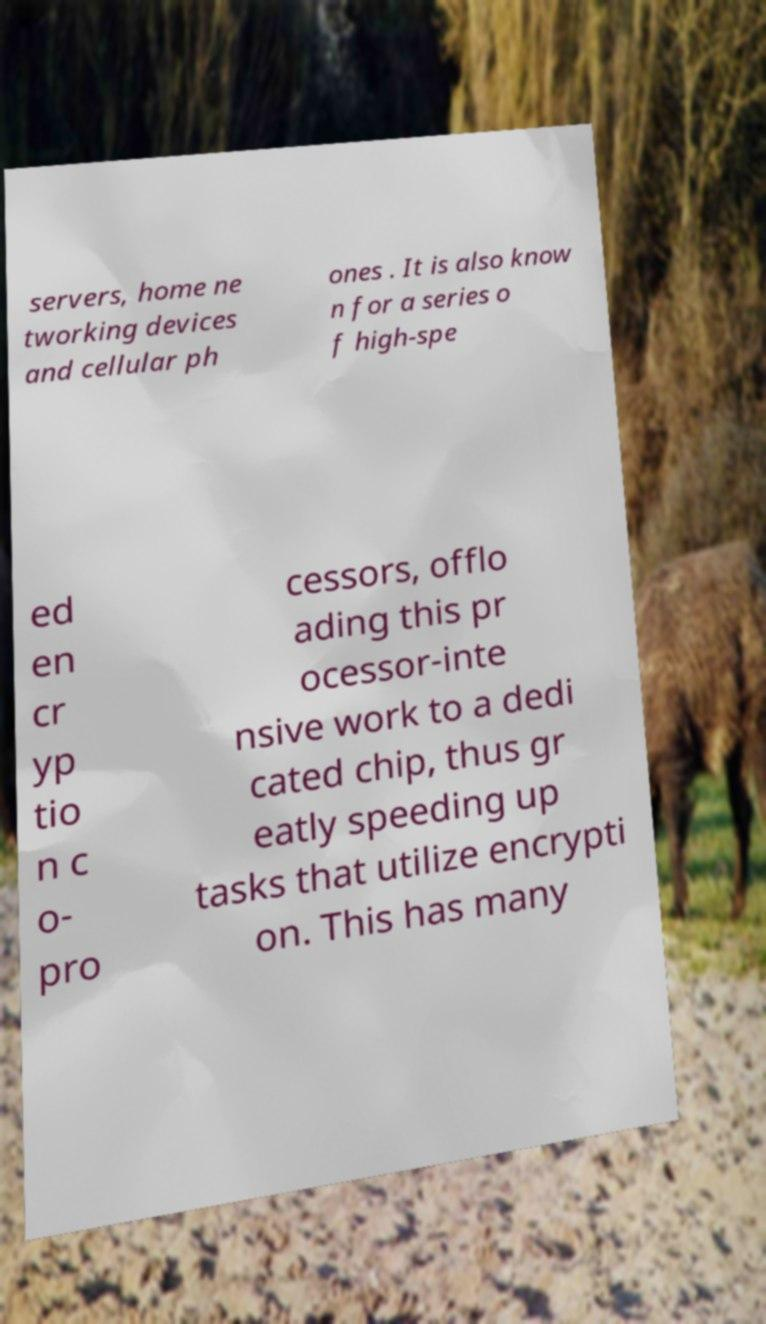What messages or text are displayed in this image? I need them in a readable, typed format. servers, home ne tworking devices and cellular ph ones . It is also know n for a series o f high-spe ed en cr yp tio n c o- pro cessors, offlo ading this pr ocessor-inte nsive work to a dedi cated chip, thus gr eatly speeding up tasks that utilize encrypti on. This has many 